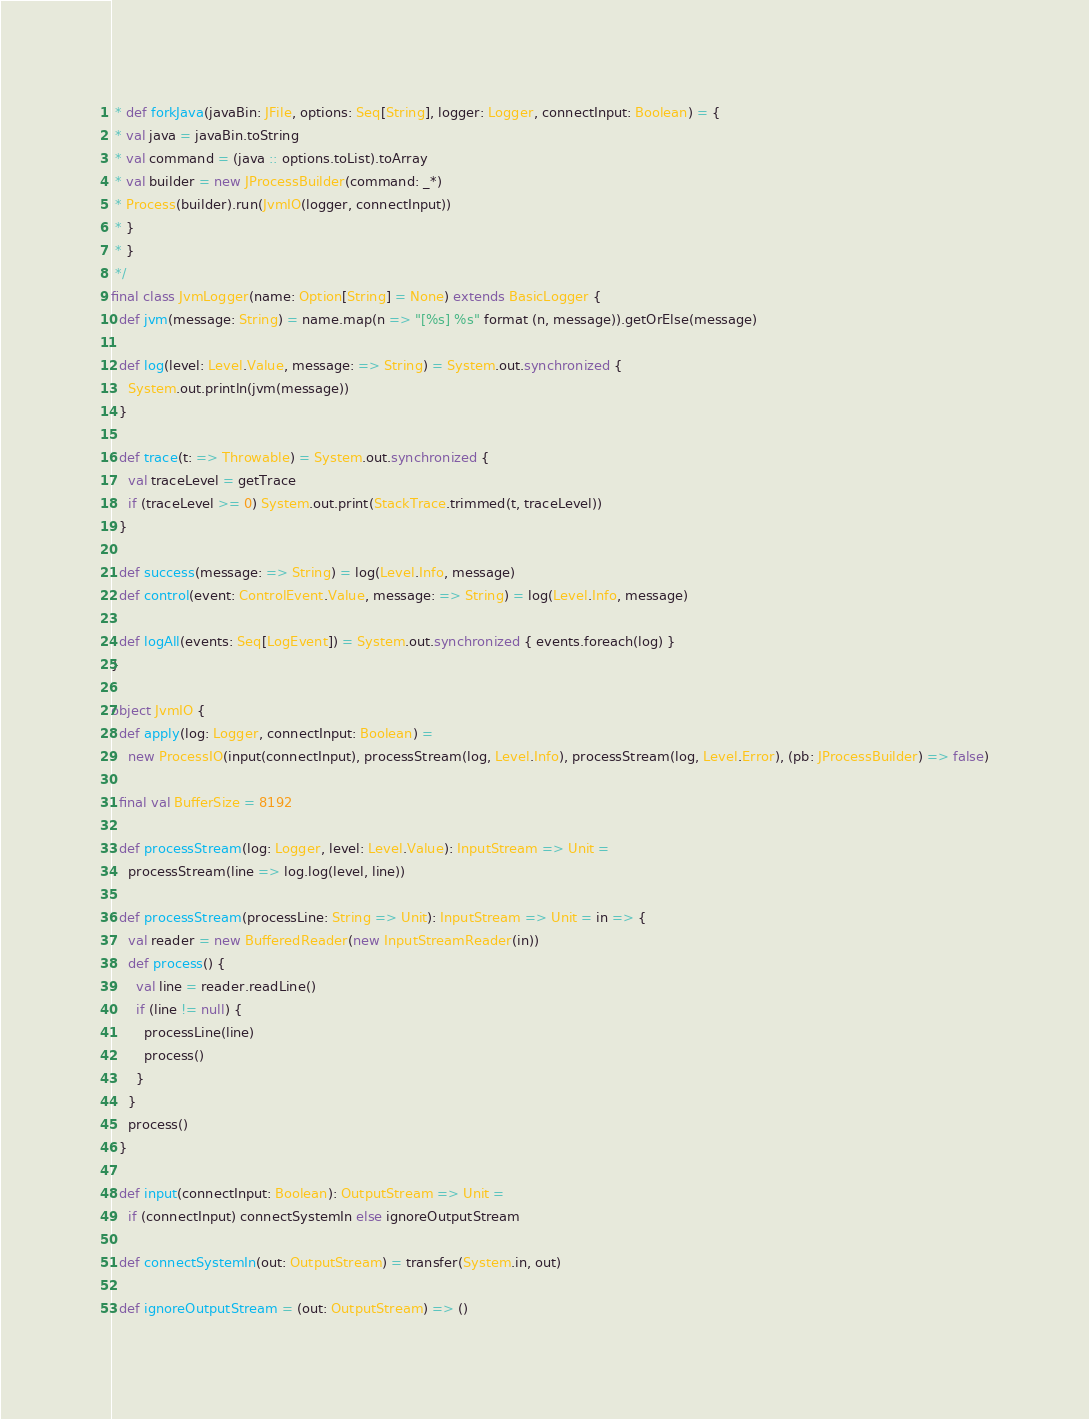Convert code to text. <code><loc_0><loc_0><loc_500><loc_500><_Scala_> * def forkJava(javaBin: JFile, options: Seq[String], logger: Logger, connectInput: Boolean) = {
 * val java = javaBin.toString
 * val command = (java :: options.toList).toArray
 * val builder = new JProcessBuilder(command: _*)
 * Process(builder).run(JvmIO(logger, connectInput))
 * }
 * }
 */
final class JvmLogger(name: Option[String] = None) extends BasicLogger {
  def jvm(message: String) = name.map(n => "[%s] %s" format (n, message)).getOrElse(message)

  def log(level: Level.Value, message: => String) = System.out.synchronized {
    System.out.println(jvm(message))
  }

  def trace(t: => Throwable) = System.out.synchronized {
    val traceLevel = getTrace
    if (traceLevel >= 0) System.out.print(StackTrace.trimmed(t, traceLevel))
  }

  def success(message: => String) = log(Level.Info, message)
  def control(event: ControlEvent.Value, message: => String) = log(Level.Info, message)

  def logAll(events: Seq[LogEvent]) = System.out.synchronized { events.foreach(log) }
}

object JvmIO {
  def apply(log: Logger, connectInput: Boolean) =
    new ProcessIO(input(connectInput), processStream(log, Level.Info), processStream(log, Level.Error), (pb: JProcessBuilder) => false)

  final val BufferSize = 8192

  def processStream(log: Logger, level: Level.Value): InputStream => Unit =
    processStream(line => log.log(level, line))

  def processStream(processLine: String => Unit): InputStream => Unit = in => {
    val reader = new BufferedReader(new InputStreamReader(in))
    def process() {
      val line = reader.readLine()
      if (line != null) {
        processLine(line)
        process()
      }
    }
    process()
  }

  def input(connectInput: Boolean): OutputStream => Unit =
    if (connectInput) connectSystemIn else ignoreOutputStream

  def connectSystemIn(out: OutputStream) = transfer(System.in, out)

  def ignoreOutputStream = (out: OutputStream) => ()
</code> 